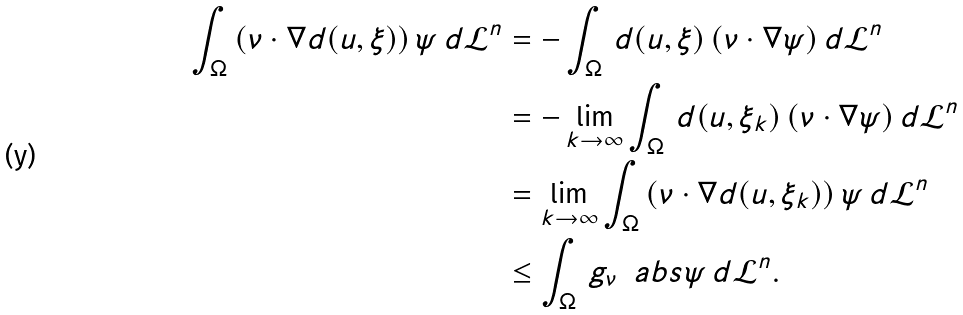Convert formula to latex. <formula><loc_0><loc_0><loc_500><loc_500>\int _ { \Omega } \, ( \nu \cdot \nabla d ( u , \xi ) ) \, \psi \, d \mathcal { L } ^ { n } & = - \int _ { \Omega } \, d ( u , \xi ) \, ( \nu \cdot \nabla \psi ) \, d \mathcal { L } ^ { n } \\ & = - \lim _ { k \to \infty } \int _ { \Omega } \, d ( u , \xi _ { k } ) \, ( \nu \cdot \nabla \psi ) \, d \mathcal { L } ^ { n } \\ & = \lim _ { k \to \infty } \int _ { \Omega } \, ( \nu \cdot \nabla d ( u , \xi _ { k } ) ) \, \psi \, d \mathcal { L } ^ { n } \\ & \leq \int _ { \Omega } \, g _ { \nu } \, \ a b s { \psi } \, d \mathcal { L } ^ { n } .</formula> 